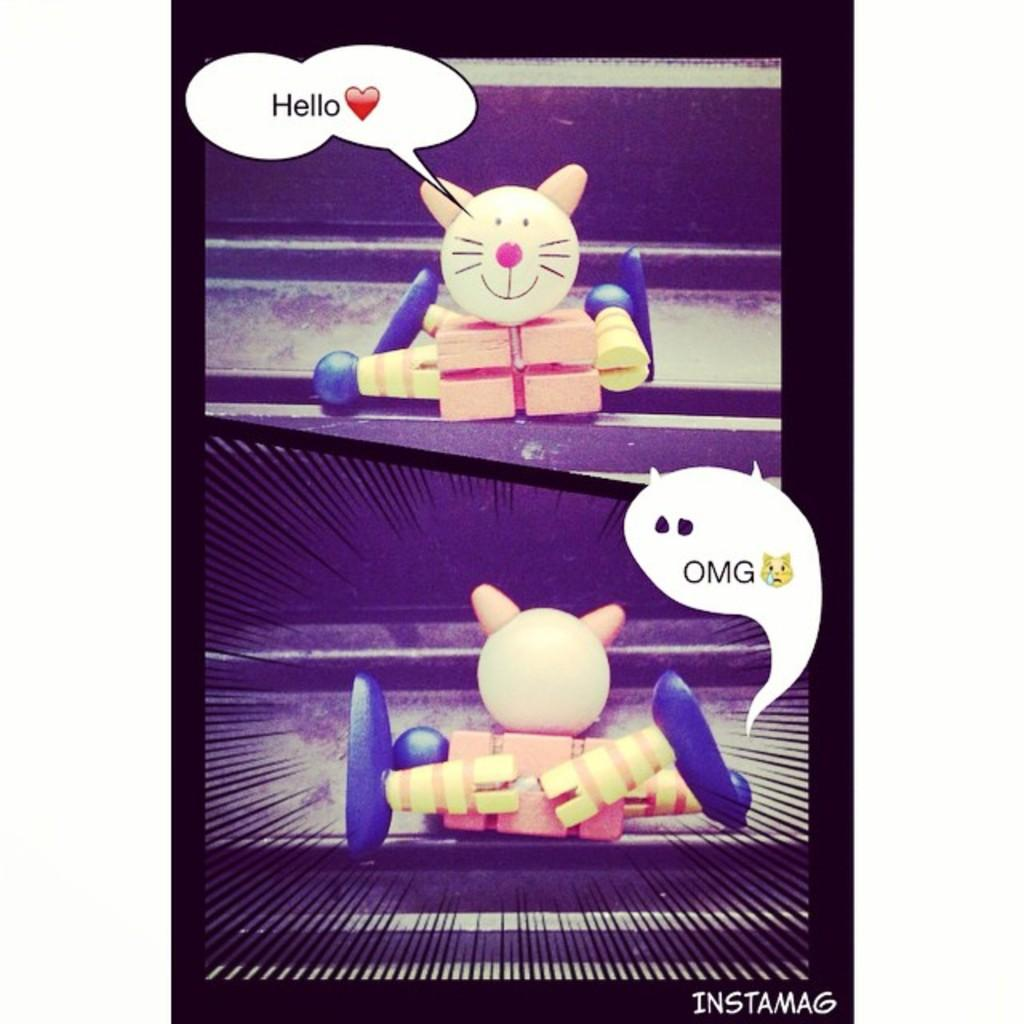What type of objects can be seen in the image? There are toys in the image. What else can be seen in the image besides toys? There are emojis and words in the image. How many fingers are visible in the image? There is no mention of fingers in the image, so it is not possible to determine how many are visible. 